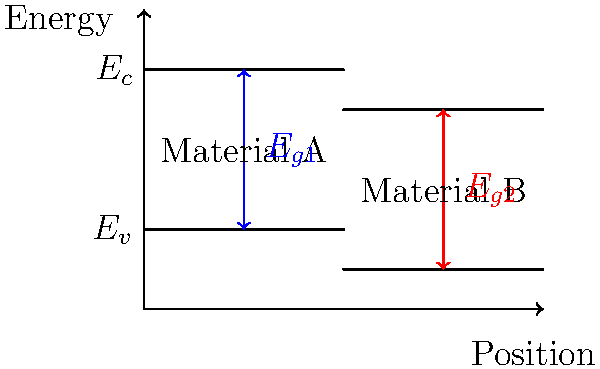In the energy band diagram shown above, which material (A or B) has a larger bandgap? How might this difference in bandgap affect the electrical properties of these materials? To answer this question, we need to analyze the energy band diagram and understand the concept of bandgap in semiconductors. Let's break it down step-by-step:

1. Bandgap definition: The bandgap is the energy difference between the conduction band minimum ($E_c$) and the valence band maximum ($E_v$).

2. Analyzing Material A:
   - The conduction band edge is at a higher energy level.
   - The valence band edge is also at a higher energy level.
   - The bandgap ($E_{g1}$) is represented by the blue arrow.

3. Analyzing Material B:
   - Both the conduction and valence band edges are at lower energy levels compared to Material A.
   - The bandgap ($E_{g2}$) is represented by the red arrow.

4. Comparing bandgaps:
   - Visually, we can see that the blue arrow ($E_{g1}$) for Material A is longer than the red arrow ($E_{g2}$) for Material B.
   - This indicates that Material A has a larger bandgap than Material B.

5. Effects on electrical properties:
   - A larger bandgap typically results in:
     a) Higher resistivity
     b) Lower intrinsic carrier concentration
     c) Higher breakdown voltage
     d) Better thermal stability
   - A smaller bandgap typically results in:
     a) Lower resistivity
     b) Higher intrinsic carrier concentration
     c) Lower breakdown voltage
     d) More sensitive to temperature changes

Therefore, Material A, with its larger bandgap, would likely have higher resistivity, lower intrinsic carrier concentration, higher breakdown voltage, and better thermal stability compared to Material B.
Answer: Material A has a larger bandgap, resulting in higher resistivity, lower intrinsic carrier concentration, higher breakdown voltage, and better thermal stability compared to Material B. 